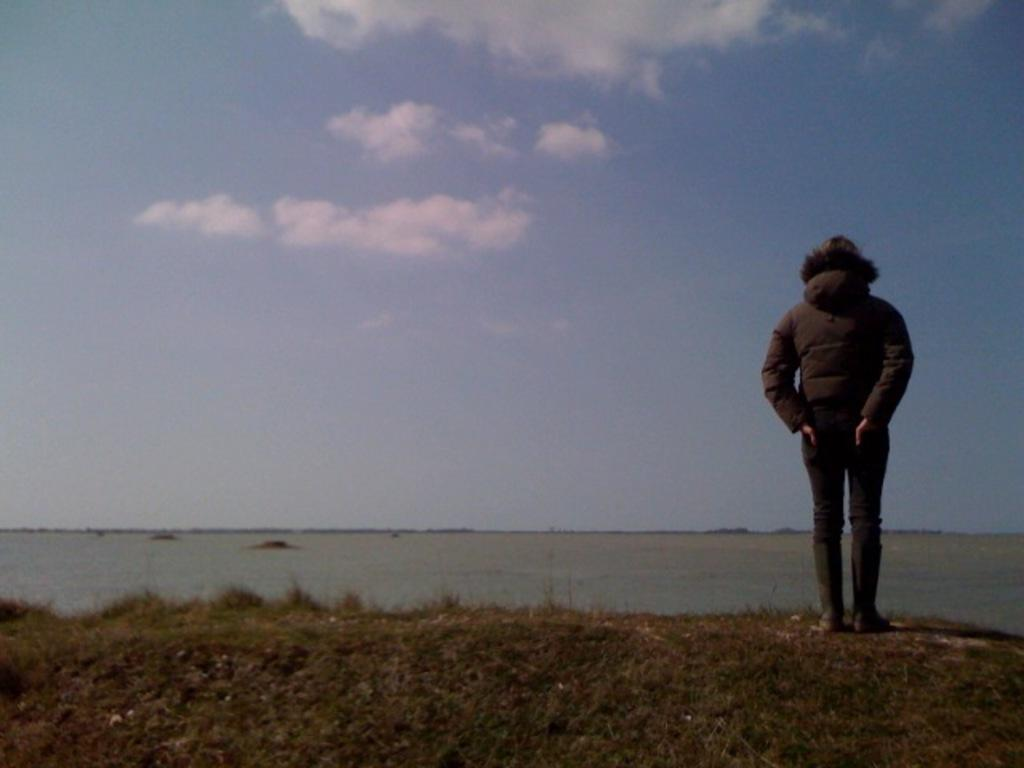What is the main subject of the image? There is a person standing in the image. What is the person standing on? The person is standing on grassy land. What can be seen behind the person? There is water visible behind the person. What is visible at the top of the image? The sky is visible at the top of the image. What type of soup is the person holding in the image? There is no soup present in the image; the person is standing on grassy land with water visible behind them. 